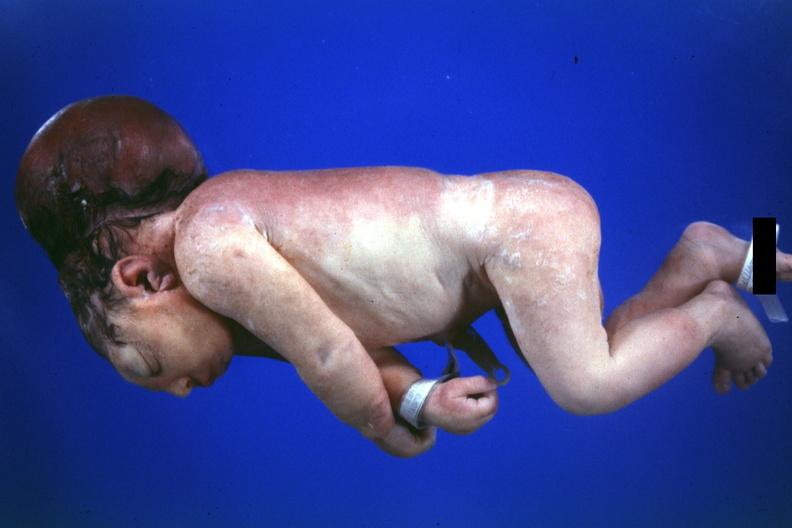s brain present?
Answer the question using a single word or phrase. Yes 